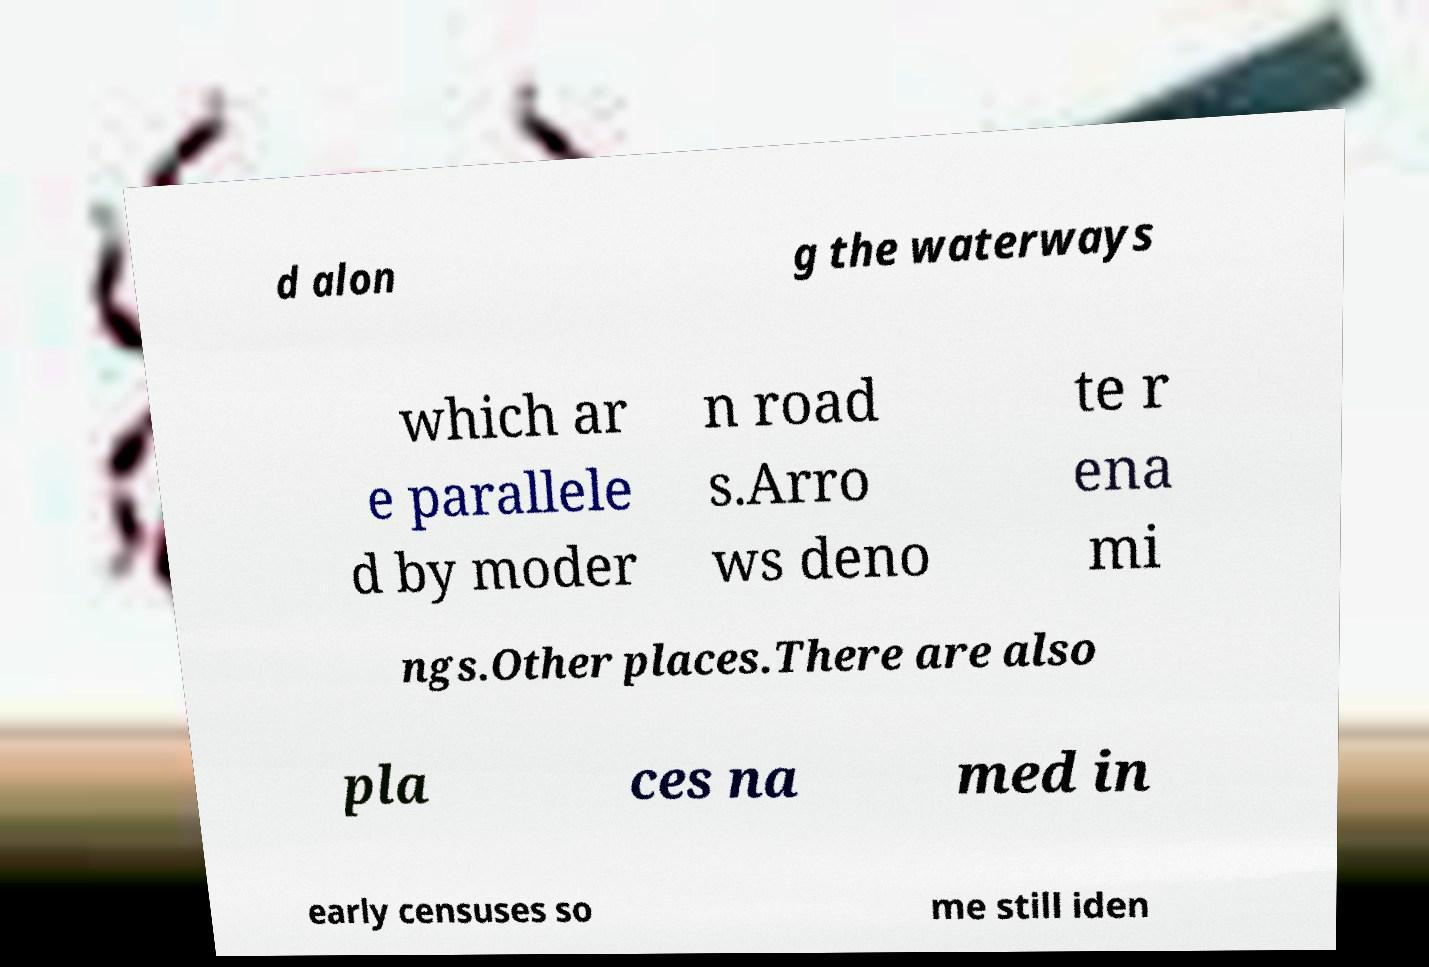I need the written content from this picture converted into text. Can you do that? d alon g the waterways which ar e parallele d by moder n road s.Arro ws deno te r ena mi ngs.Other places.There are also pla ces na med in early censuses so me still iden 